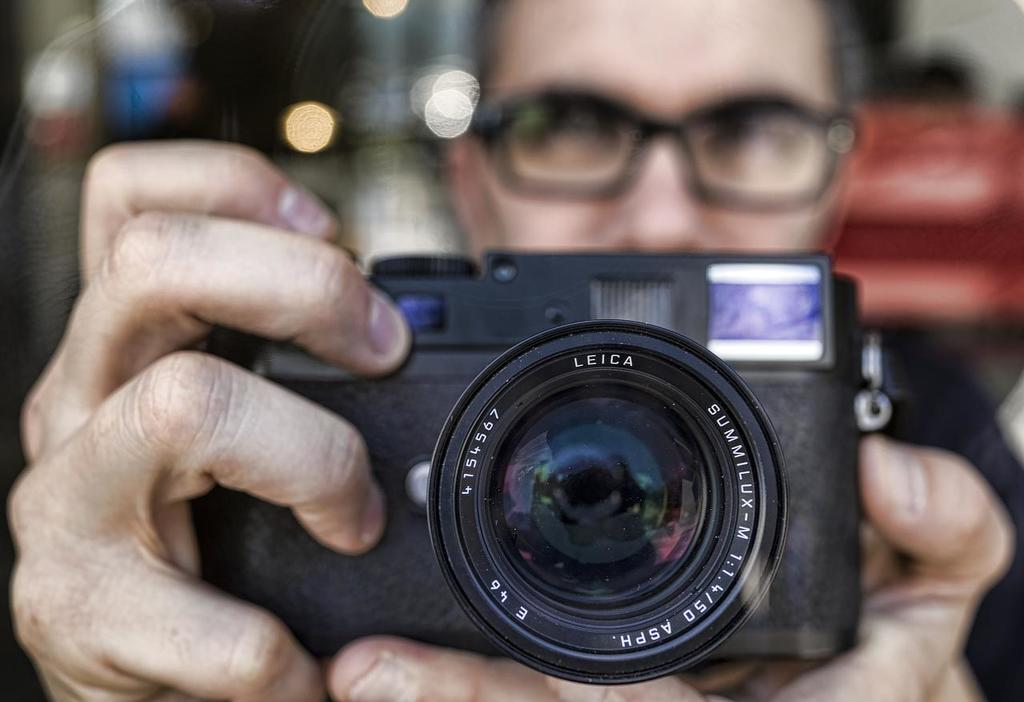What is the main subject of the image? There is a man in the image. What is the man holding in the image? The man is holding a camera. What scientific theory is the man contemplating in the image? There is no indication in the image that the man is contemplating any scientific theory. 